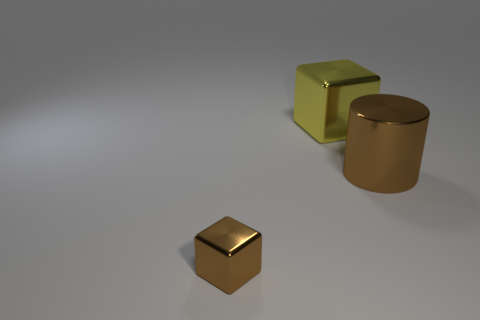Subtract 1 cylinders. How many cylinders are left? 0 Subtract all purple cubes. Subtract all yellow spheres. How many cubes are left? 2 Add 1 brown cylinders. How many objects exist? 4 Subtract all cylinders. How many objects are left? 2 Add 1 big cyan metal things. How many big cyan metal things exist? 1 Subtract 0 cyan cylinders. How many objects are left? 3 Subtract all purple rubber cylinders. Subtract all large brown metal cylinders. How many objects are left? 2 Add 3 brown metal objects. How many brown metal objects are left? 5 